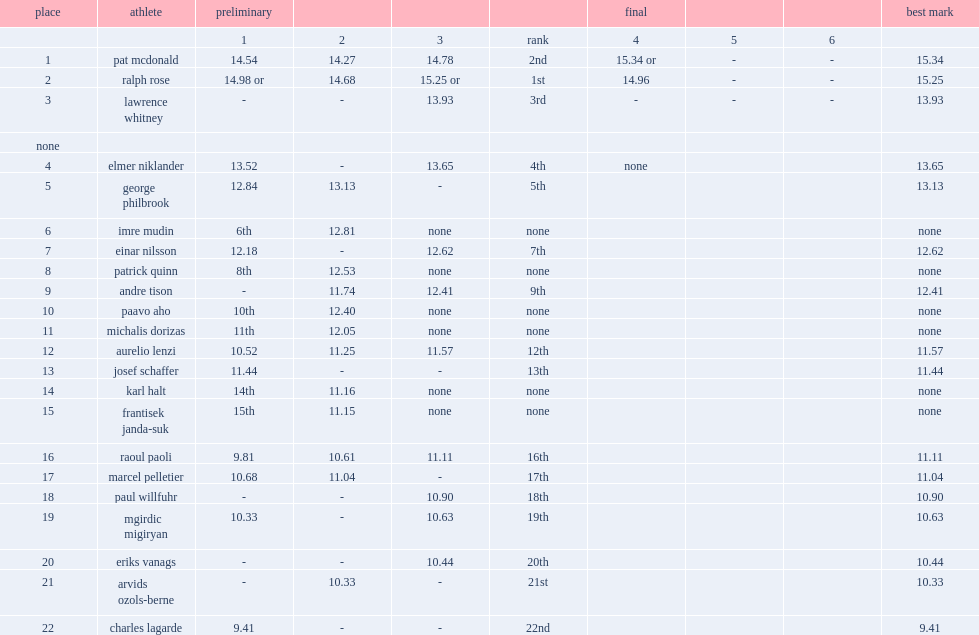What was rose's result at the end of the preliminaries? 15.25 or. 